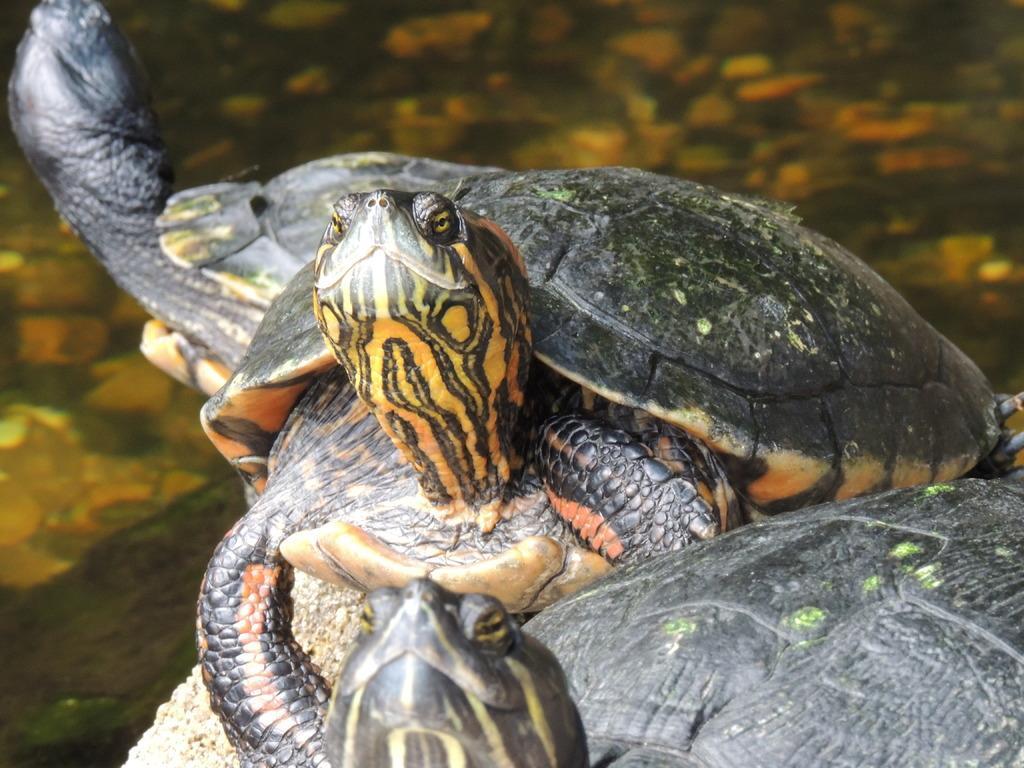Describe this image in one or two sentences. In this image we can see three Florida-red belly turtles. 